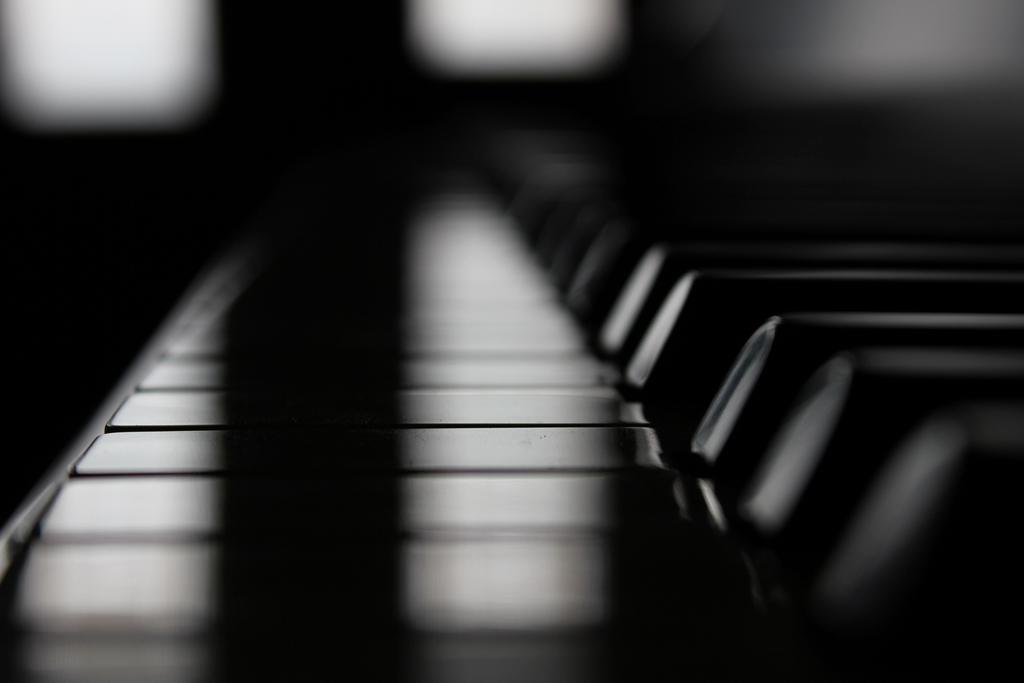What is the overall lighting condition of the image? The image is dark. Where are the black color buttons located in the image? The black color buttons are on the right side of the image. What type of truck can be seen driving through the image? There is no truck present in the image; it is dark with black color buttons on the right side. 